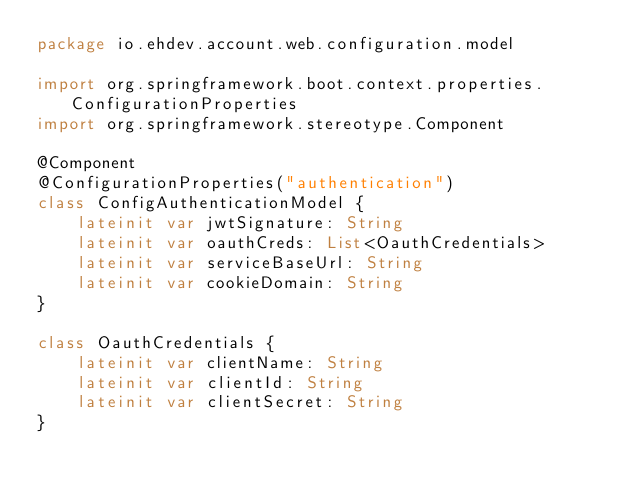<code> <loc_0><loc_0><loc_500><loc_500><_Kotlin_>package io.ehdev.account.web.configuration.model

import org.springframework.boot.context.properties.ConfigurationProperties
import org.springframework.stereotype.Component

@Component
@ConfigurationProperties("authentication")
class ConfigAuthenticationModel {
    lateinit var jwtSignature: String
    lateinit var oauthCreds: List<OauthCredentials>
    lateinit var serviceBaseUrl: String
    lateinit var cookieDomain: String
}

class OauthCredentials {
    lateinit var clientName: String
    lateinit var clientId: String
    lateinit var clientSecret: String
}</code> 